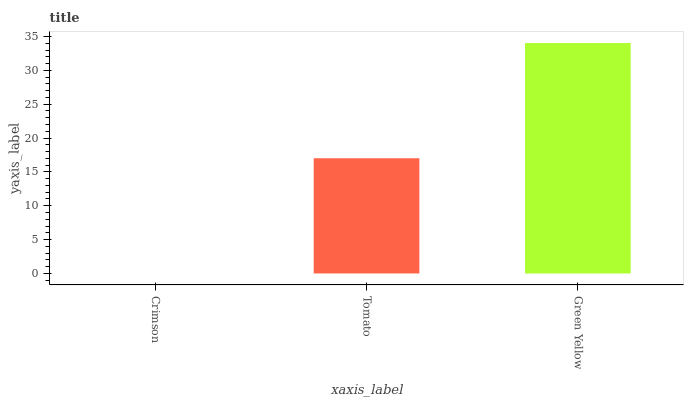Is Tomato the minimum?
Answer yes or no. No. Is Tomato the maximum?
Answer yes or no. No. Is Tomato greater than Crimson?
Answer yes or no. Yes. Is Crimson less than Tomato?
Answer yes or no. Yes. Is Crimson greater than Tomato?
Answer yes or no. No. Is Tomato less than Crimson?
Answer yes or no. No. Is Tomato the high median?
Answer yes or no. Yes. Is Tomato the low median?
Answer yes or no. Yes. Is Green Yellow the high median?
Answer yes or no. No. Is Crimson the low median?
Answer yes or no. No. 